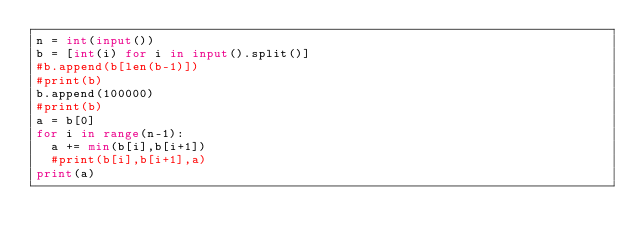Convert code to text. <code><loc_0><loc_0><loc_500><loc_500><_Python_>n = int(input())
b = [int(i) for i in input().split()]
#b.append(b[len(b-1)])
#print(b)
b.append(100000)
#print(b)
a = b[0]
for i in range(n-1):
  a += min(b[i],b[i+1])
  #print(b[i],b[i+1],a)
print(a)</code> 